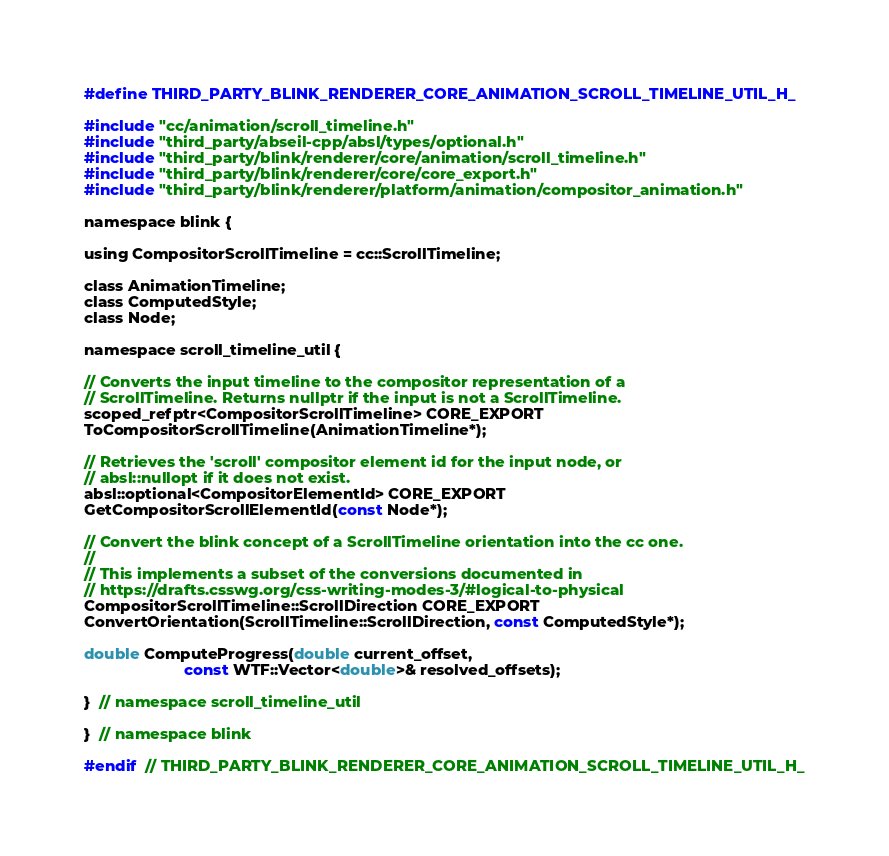Convert code to text. <code><loc_0><loc_0><loc_500><loc_500><_C_>#define THIRD_PARTY_BLINK_RENDERER_CORE_ANIMATION_SCROLL_TIMELINE_UTIL_H_

#include "cc/animation/scroll_timeline.h"
#include "third_party/abseil-cpp/absl/types/optional.h"
#include "third_party/blink/renderer/core/animation/scroll_timeline.h"
#include "third_party/blink/renderer/core/core_export.h"
#include "third_party/blink/renderer/platform/animation/compositor_animation.h"

namespace blink {

using CompositorScrollTimeline = cc::ScrollTimeline;

class AnimationTimeline;
class ComputedStyle;
class Node;

namespace scroll_timeline_util {

// Converts the input timeline to the compositor representation of a
// ScrollTimeline. Returns nullptr if the input is not a ScrollTimeline.
scoped_refptr<CompositorScrollTimeline> CORE_EXPORT
ToCompositorScrollTimeline(AnimationTimeline*);

// Retrieves the 'scroll' compositor element id for the input node, or
// absl::nullopt if it does not exist.
absl::optional<CompositorElementId> CORE_EXPORT
GetCompositorScrollElementId(const Node*);

// Convert the blink concept of a ScrollTimeline orientation into the cc one.
//
// This implements a subset of the conversions documented in
// https://drafts.csswg.org/css-writing-modes-3/#logical-to-physical
CompositorScrollTimeline::ScrollDirection CORE_EXPORT
ConvertOrientation(ScrollTimeline::ScrollDirection, const ComputedStyle*);

double ComputeProgress(double current_offset,
                       const WTF::Vector<double>& resolved_offsets);

}  // namespace scroll_timeline_util

}  // namespace blink

#endif  // THIRD_PARTY_BLINK_RENDERER_CORE_ANIMATION_SCROLL_TIMELINE_UTIL_H_
</code> 